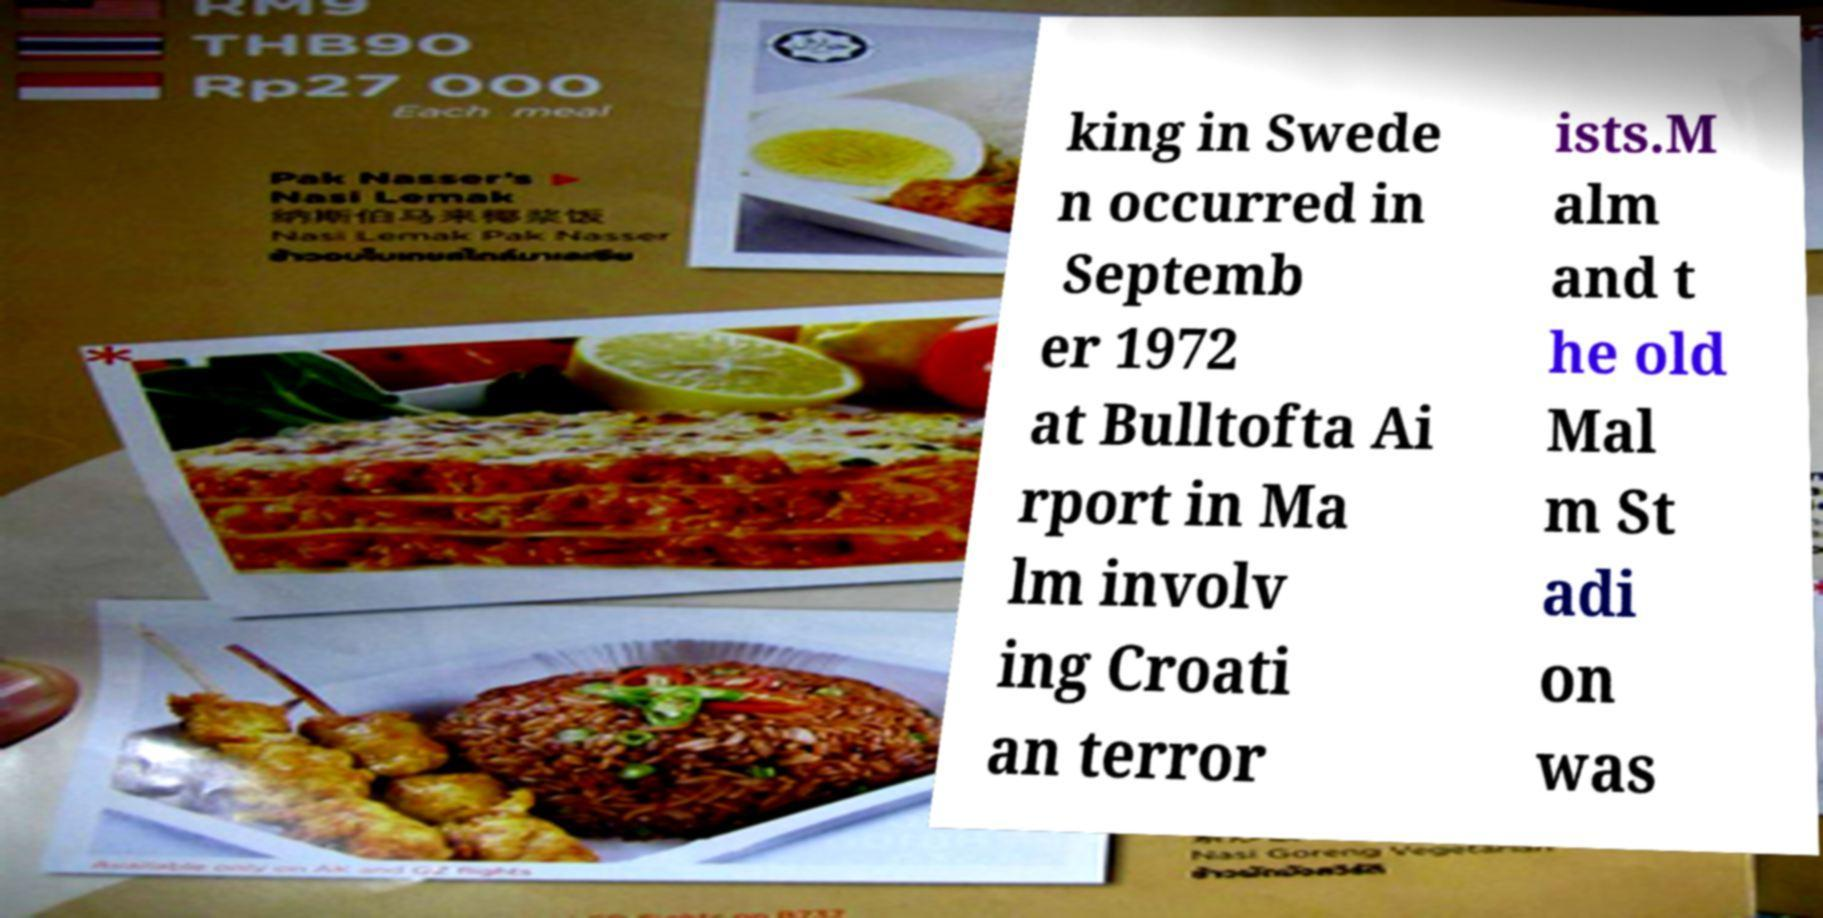There's text embedded in this image that I need extracted. Can you transcribe it verbatim? king in Swede n occurred in Septemb er 1972 at Bulltofta Ai rport in Ma lm involv ing Croati an terror ists.M alm and t he old Mal m St adi on was 